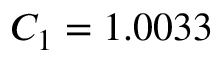Convert formula to latex. <formula><loc_0><loc_0><loc_500><loc_500>C _ { 1 } = 1 . 0 0 3 3</formula> 